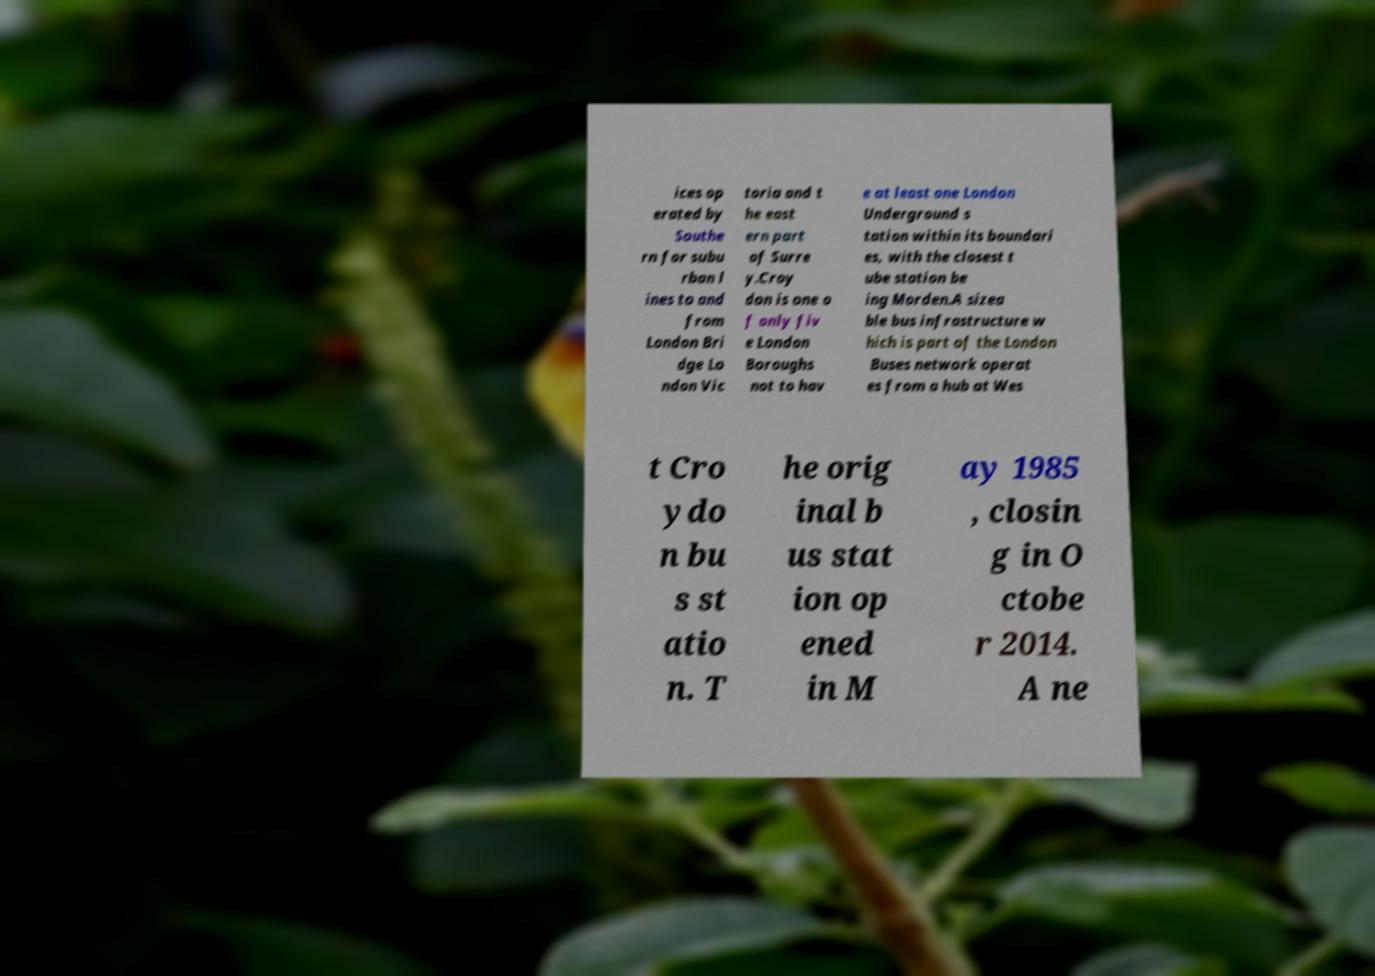What messages or text are displayed in this image? I need them in a readable, typed format. ices op erated by Southe rn for subu rban l ines to and from London Bri dge Lo ndon Vic toria and t he east ern part of Surre y.Croy don is one o f only fiv e London Boroughs not to hav e at least one London Underground s tation within its boundari es, with the closest t ube station be ing Morden.A sizea ble bus infrastructure w hich is part of the London Buses network operat es from a hub at Wes t Cro ydo n bu s st atio n. T he orig inal b us stat ion op ened in M ay 1985 , closin g in O ctobe r 2014. A ne 